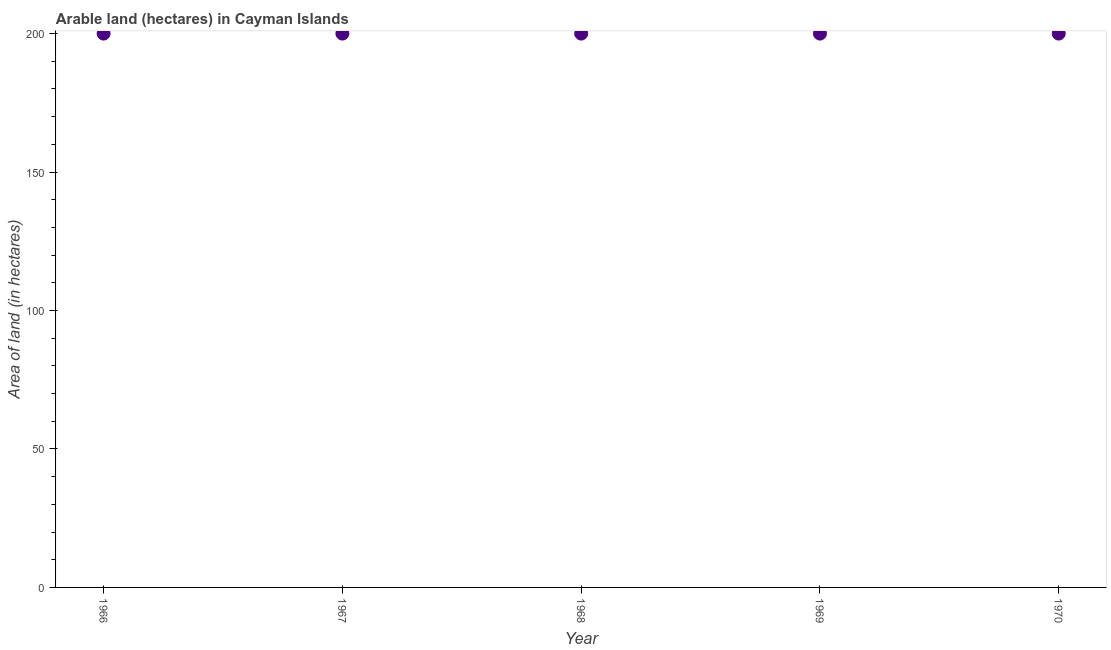What is the area of land in 1967?
Make the answer very short. 200. Across all years, what is the maximum area of land?
Give a very brief answer. 200. Across all years, what is the minimum area of land?
Provide a short and direct response. 200. In which year was the area of land maximum?
Your answer should be very brief. 1966. In which year was the area of land minimum?
Provide a short and direct response. 1966. What is the sum of the area of land?
Make the answer very short. 1000. What is the average area of land per year?
Provide a succinct answer. 200. What is the median area of land?
Your answer should be compact. 200. In how many years, is the area of land greater than 110 hectares?
Offer a terse response. 5. What is the ratio of the area of land in 1966 to that in 1968?
Your answer should be very brief. 1. Is the area of land in 1966 less than that in 1969?
Your answer should be compact. No. What is the difference between the highest and the lowest area of land?
Ensure brevity in your answer.  0. In how many years, is the area of land greater than the average area of land taken over all years?
Ensure brevity in your answer.  0. How many dotlines are there?
Offer a terse response. 1. What is the difference between two consecutive major ticks on the Y-axis?
Your answer should be very brief. 50. Are the values on the major ticks of Y-axis written in scientific E-notation?
Your response must be concise. No. Does the graph contain any zero values?
Provide a short and direct response. No. What is the title of the graph?
Give a very brief answer. Arable land (hectares) in Cayman Islands. What is the label or title of the X-axis?
Offer a terse response. Year. What is the label or title of the Y-axis?
Provide a succinct answer. Area of land (in hectares). What is the Area of land (in hectares) in 1969?
Ensure brevity in your answer.  200. What is the difference between the Area of land (in hectares) in 1966 and 1970?
Provide a short and direct response. 0. What is the difference between the Area of land (in hectares) in 1967 and 1970?
Offer a terse response. 0. What is the difference between the Area of land (in hectares) in 1968 and 1969?
Ensure brevity in your answer.  0. What is the difference between the Area of land (in hectares) in 1968 and 1970?
Your answer should be compact. 0. What is the ratio of the Area of land (in hectares) in 1966 to that in 1967?
Provide a short and direct response. 1. What is the ratio of the Area of land (in hectares) in 1966 to that in 1970?
Keep it short and to the point. 1. What is the ratio of the Area of land (in hectares) in 1967 to that in 1968?
Your answer should be compact. 1. What is the ratio of the Area of land (in hectares) in 1967 to that in 1969?
Make the answer very short. 1. What is the ratio of the Area of land (in hectares) in 1968 to that in 1970?
Your response must be concise. 1. What is the ratio of the Area of land (in hectares) in 1969 to that in 1970?
Your answer should be very brief. 1. 